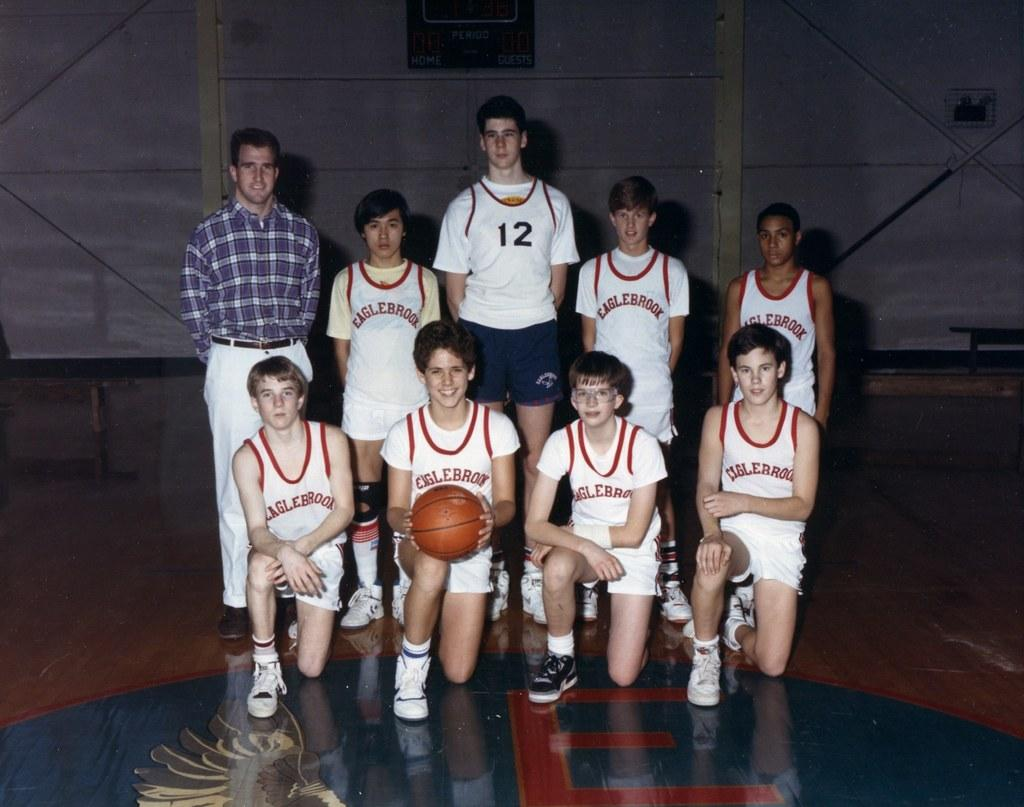<image>
Provide a brief description of the given image. A group of basketball players from the school Eaglebrook 